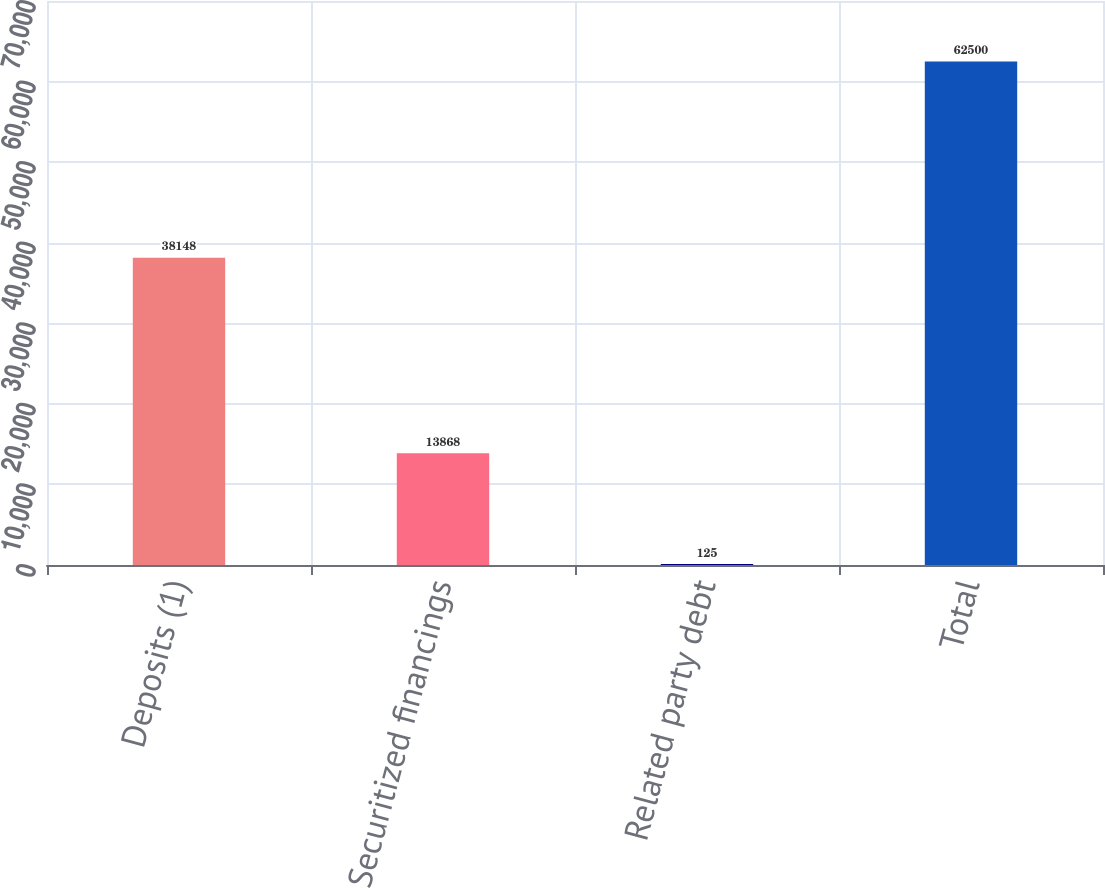Convert chart. <chart><loc_0><loc_0><loc_500><loc_500><bar_chart><fcel>Deposits (1)<fcel>Securitized financings<fcel>Related party debt<fcel>Total<nl><fcel>38148<fcel>13868<fcel>125<fcel>62500<nl></chart> 